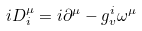<formula> <loc_0><loc_0><loc_500><loc_500>i D ^ { \mu } _ { i } = i \partial ^ { \mu } - g _ { v } ^ { i } \omega ^ { \mu }</formula> 